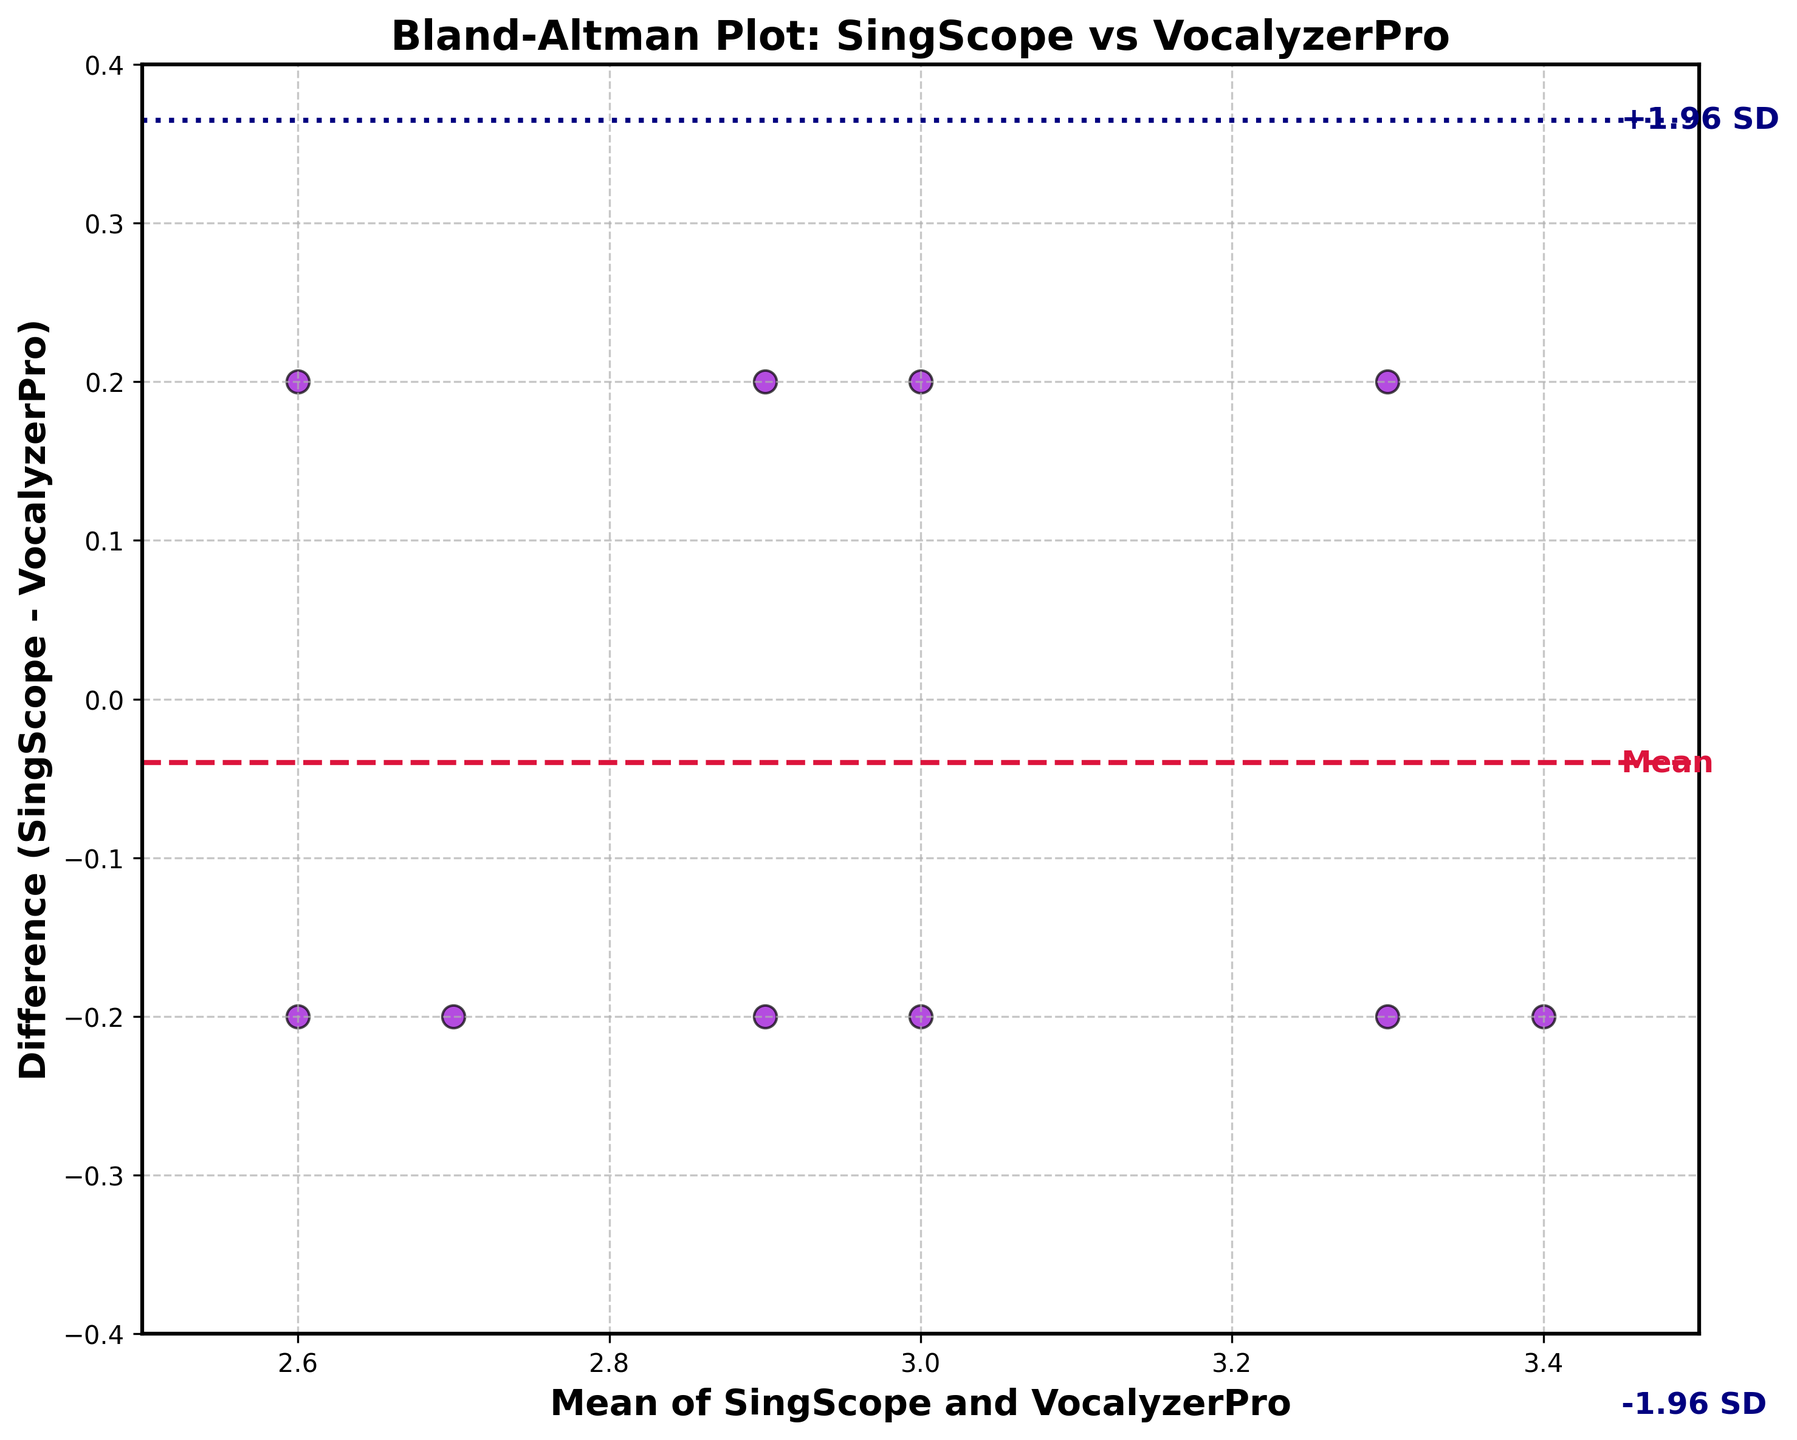What's the title of the plot? The title of the plot is typically placed at the top of the figure and clearly states what the plot is about. In this case, the title is "Bland-Altman Plot: SingScope vs VocalyzerPro"
Answer: Bland-Altman Plot: SingScope vs VocalyzerPro What do the x-axis and y-axis represent? The x-axis represents the mean of the vocal range measurements from SingScope and VocalyzerPro software, while the y-axis represents the difference between the measurements taken by SingScope and VocalyzerPro (SingScope - VocalyzerPro). This is indicated by the labels on the axes.
Answer: Mean of SingScope and VocalyzerPro (x-axis), Difference (SingScope - VocalyzerPro) (y-axis) How many data points are plotted in the figure? Each data point on a Bland-Altman plot represents a pair of measurements. By counting the purple dots in the scatter plot, you can see that there are 10 data points, each corresponding to a jazz singer.
Answer: 10 What are the limits of agreement in this plot? The limits of agreement are calculated as the mean difference ± 1.96 times the standard deviation of the difference. In the plot, these limits are represented by dashed lines above and below the mean difference line. Specifically, the limits are labeled "+1.96 SD" and "-1.96 SD" and are depicted at approximately 0.18 and -0.22.
Answer: 0.18 (upper), -0.22 (lower) What color is used to represent the mean difference line? The mean difference line is indicated on the plot with a distinct color and style. In this case, the mean difference line is shown in crimson with a dashed line style, which is also labeled as 'Mean' on the plot.
Answer: Crimson Who has the highest mean vocal range between the two software? The highest mean vocal range can be determined by looking at the x-axis values of the plotted points. The highest mean value is at 3.4, which corresponds to the singers Gregory Porter and Ella Fitzgerald.
Answer: Gregory Porter and Ella Fitzgerald Which singer shows the largest positive difference in vocal range measurements between SingScope and VocalyzerPro? To determine this, look at the y-axis for the highest positive difference value. The point with the largest positive difference is for Gregory Porter, which is positioned at (3.4, 0.2).
Answer: Gregory Porter What's the average of the mean vocal ranges for the singers Diana Krall and Norah Jones? First, identify the mean vocal ranges for Diana Krall (2.9) and Norah Jones (2.7). Then, calculate the average: (2.9 + 2.7) / 2 = 2.8
Answer: 2.8 Which singer has a negative difference in their vocal range measurements, and what is that difference? A negative difference means that SingScope measured a lower vocal range than VocalyzerPro. From the plot, Melody Gardot's data point is below the zero line on the y-axis, and her difference is -0.2
Answer: Melody Gardot, -0.2 